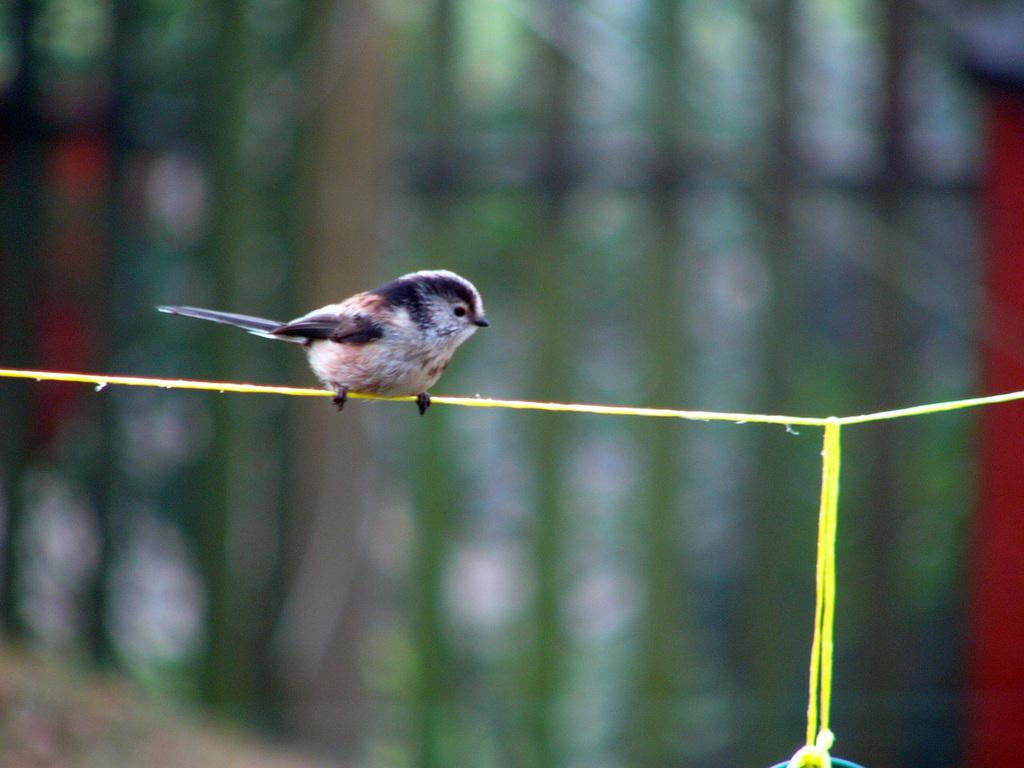What type of animal is in the picture? There is a bird in the picture. Where is the bird located in the image? The bird is on a rope. What type of pancake is the bird holding in the image? There is no pancake present in the image, and the bird is not holding anything. 